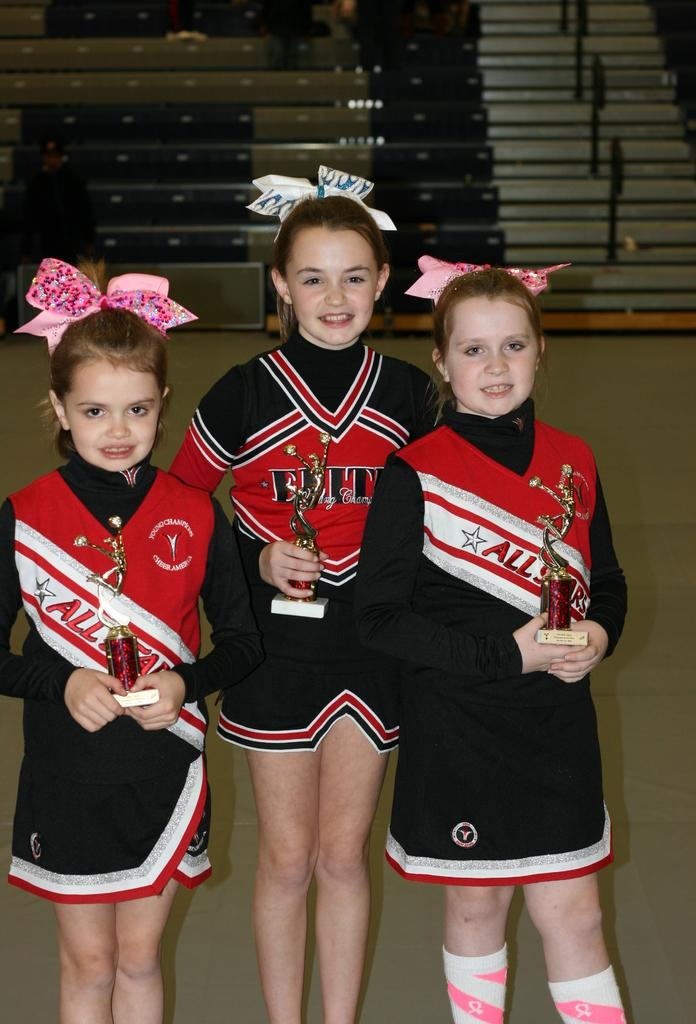<image>
Relay a brief, clear account of the picture shown. three cheerleaders the with names All on them 